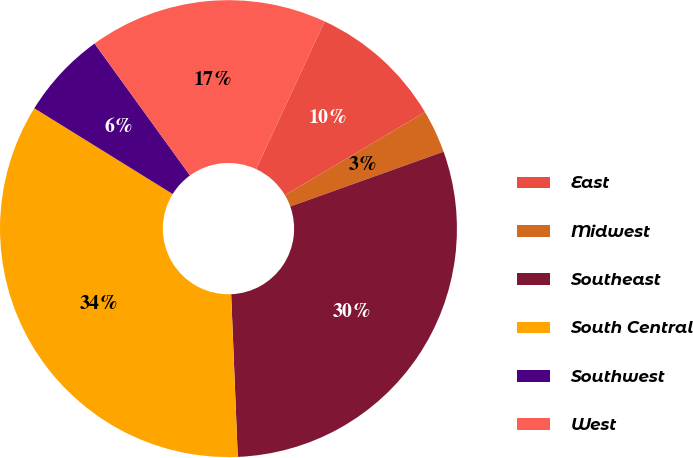Convert chart. <chart><loc_0><loc_0><loc_500><loc_500><pie_chart><fcel>East<fcel>Midwest<fcel>Southeast<fcel>South Central<fcel>Southwest<fcel>West<nl><fcel>9.57%<fcel>3.05%<fcel>29.82%<fcel>34.48%<fcel>6.2%<fcel>16.88%<nl></chart> 